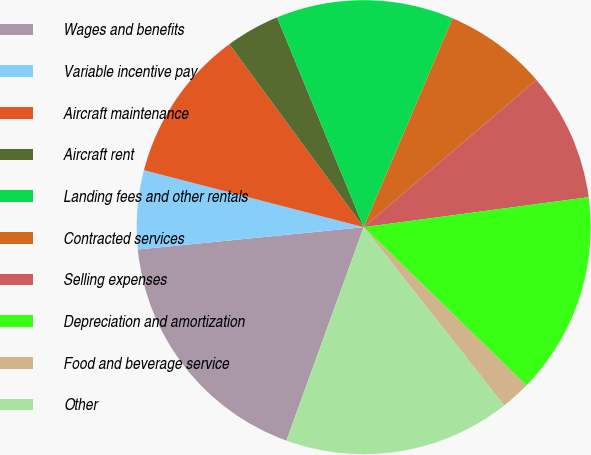Convert chart. <chart><loc_0><loc_0><loc_500><loc_500><pie_chart><fcel>Wages and benefits<fcel>Variable incentive pay<fcel>Aircraft maintenance<fcel>Aircraft rent<fcel>Landing fees and other rentals<fcel>Contracted services<fcel>Selling expenses<fcel>Depreciation and amortization<fcel>Food and beverage service<fcel>Other<nl><fcel>17.9%<fcel>5.61%<fcel>10.88%<fcel>3.85%<fcel>12.63%<fcel>7.37%<fcel>9.12%<fcel>14.39%<fcel>2.1%<fcel>16.15%<nl></chart> 